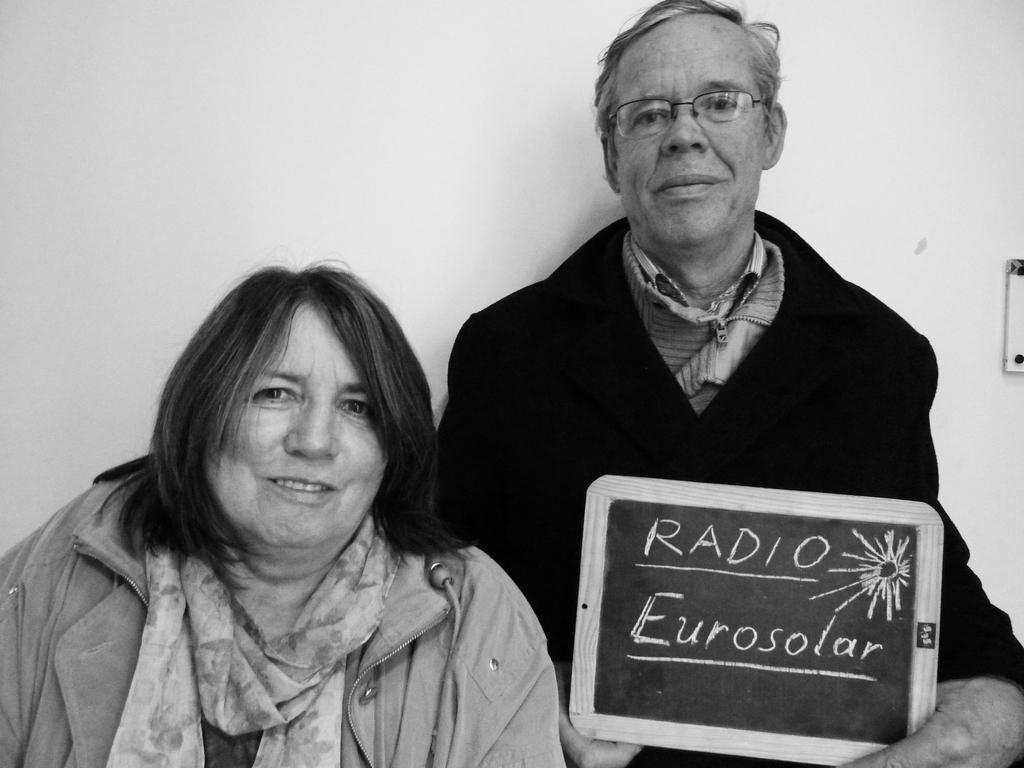Can you describe this image briefly? It is the black and white image in which there is a couple in the middle. There is a man on the right side who is holding the slate. On the left side there is a woman. On the slate there is some script. In the background there is a wall. 